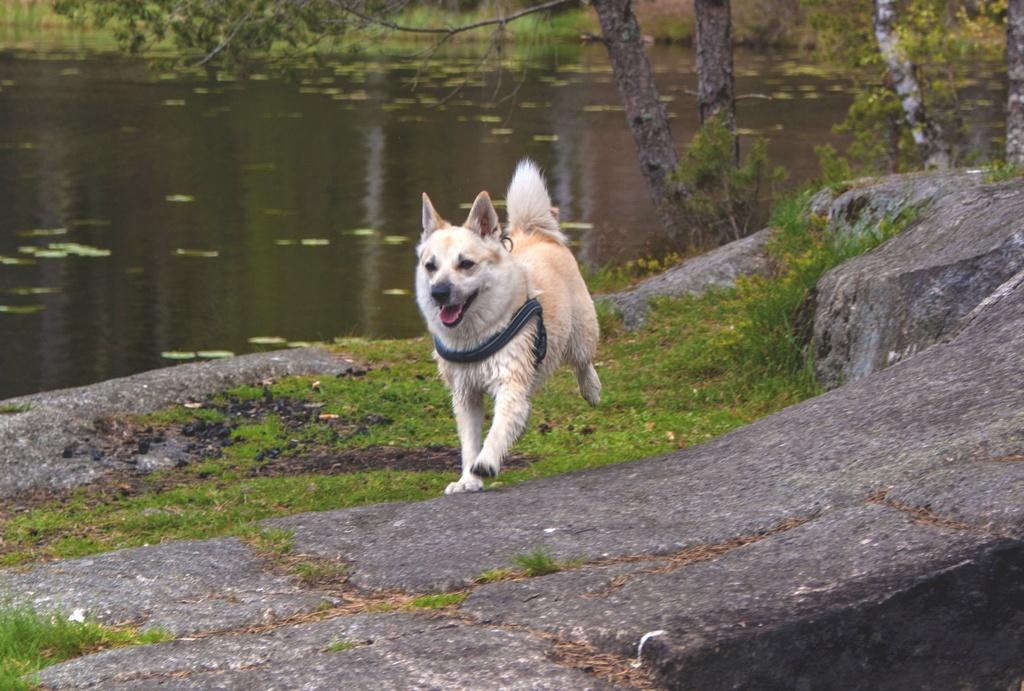What animal can be seen in the image? There is a dog in the image. What is the dog doing in the image? The dog is running on a rock. Is there any equipment attached to the dog? Yes, there is a belt tied to the dog. What can be seen in the background of the image? Water, grass, and trees are visible in the background of the image. What type of government is depicted in the image? There is no depiction of a government in the image; it features a dog running on a rock with a belt tied to it. Can you tell me how many buttons are on the dog's collar in the image? There is no collar or buttons present on the dog in the image. 